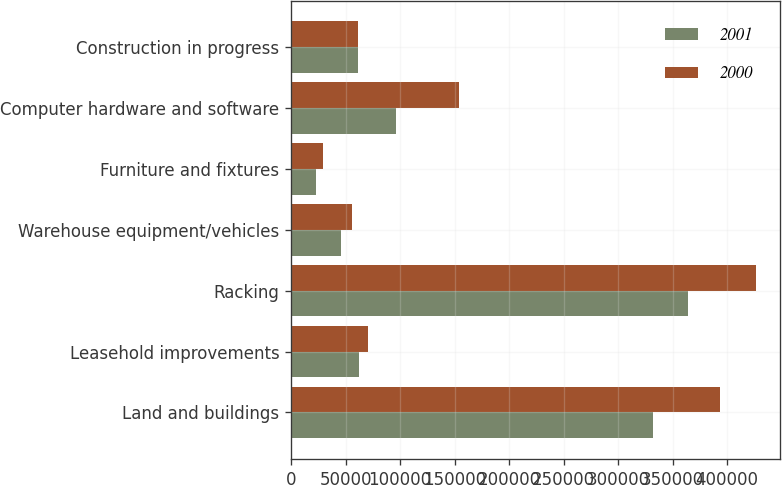Convert chart. <chart><loc_0><loc_0><loc_500><loc_500><stacked_bar_chart><ecel><fcel>Land and buildings<fcel>Leasehold improvements<fcel>Racking<fcel>Warehouse equipment/vehicles<fcel>Furniture and fixtures<fcel>Computer hardware and software<fcel>Construction in progress<nl><fcel>2001<fcel>331921<fcel>62381<fcel>364337<fcel>45532<fcel>22574<fcel>96408<fcel>61786<nl><fcel>2000<fcel>393429<fcel>70434<fcel>426776<fcel>56064<fcel>29052<fcel>153546<fcel>61236<nl></chart> 